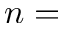<formula> <loc_0><loc_0><loc_500><loc_500>n =</formula> 